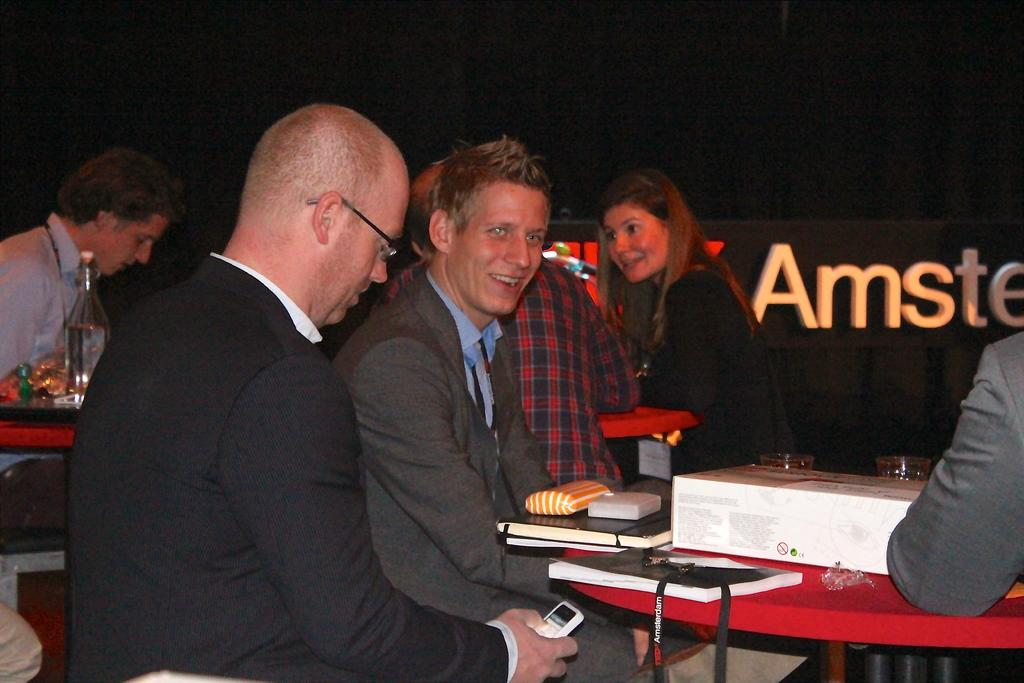What type of furniture is present in the image? There is a table in the image. What are the people near the table sitting on? People are sitting on stools near the table. What items can be seen on the table? There are books, files, boxes, bottles, and plates on the table. What type of pot is visible on the table in the image? There is no pot present on the table in the image. What kind of toy can be seen being played with by the people in the image? There are no toys visible in the image; people are sitting on stools near the table with various items on it. 